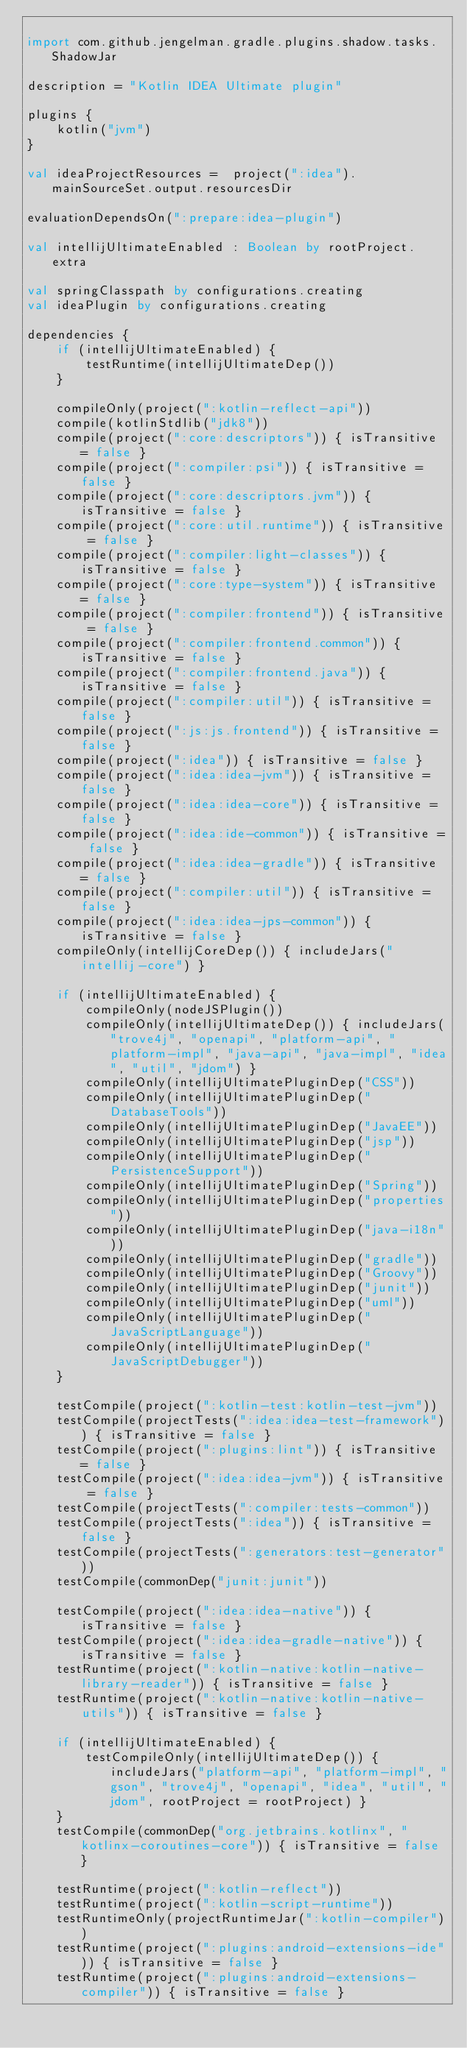<code> <loc_0><loc_0><loc_500><loc_500><_Kotlin_>
import com.github.jengelman.gradle.plugins.shadow.tasks.ShadowJar

description = "Kotlin IDEA Ultimate plugin"

plugins {
    kotlin("jvm")
}

val ideaProjectResources =  project(":idea").mainSourceSet.output.resourcesDir

evaluationDependsOn(":prepare:idea-plugin")

val intellijUltimateEnabled : Boolean by rootProject.extra

val springClasspath by configurations.creating
val ideaPlugin by configurations.creating

dependencies {
    if (intellijUltimateEnabled) {
        testRuntime(intellijUltimateDep())
    }

    compileOnly(project(":kotlin-reflect-api"))
    compile(kotlinStdlib("jdk8"))
    compile(project(":core:descriptors")) { isTransitive = false }
    compile(project(":compiler:psi")) { isTransitive = false }
    compile(project(":core:descriptors.jvm")) { isTransitive = false }
    compile(project(":core:util.runtime")) { isTransitive = false }
    compile(project(":compiler:light-classes")) { isTransitive = false }
    compile(project(":core:type-system")) { isTransitive = false }
    compile(project(":compiler:frontend")) { isTransitive = false }
    compile(project(":compiler:frontend.common")) { isTransitive = false }
    compile(project(":compiler:frontend.java")) { isTransitive = false }
    compile(project(":compiler:util")) { isTransitive = false }
    compile(project(":js:js.frontend")) { isTransitive = false }
    compile(project(":idea")) { isTransitive = false }
    compile(project(":idea:idea-jvm")) { isTransitive = false }
    compile(project(":idea:idea-core")) { isTransitive = false }
    compile(project(":idea:ide-common")) { isTransitive = false }
    compile(project(":idea:idea-gradle")) { isTransitive = false }
    compile(project(":compiler:util")) { isTransitive = false }
    compile(project(":idea:idea-jps-common")) { isTransitive = false }
    compileOnly(intellijCoreDep()) { includeJars("intellij-core") }

    if (intellijUltimateEnabled) {
        compileOnly(nodeJSPlugin())
        compileOnly(intellijUltimateDep()) { includeJars("trove4j", "openapi", "platform-api", "platform-impl", "java-api", "java-impl", "idea", "util", "jdom") }
        compileOnly(intellijUltimatePluginDep("CSS"))
        compileOnly(intellijUltimatePluginDep("DatabaseTools"))
        compileOnly(intellijUltimatePluginDep("JavaEE"))
        compileOnly(intellijUltimatePluginDep("jsp"))
        compileOnly(intellijUltimatePluginDep("PersistenceSupport"))
        compileOnly(intellijUltimatePluginDep("Spring"))
        compileOnly(intellijUltimatePluginDep("properties"))
        compileOnly(intellijUltimatePluginDep("java-i18n"))
        compileOnly(intellijUltimatePluginDep("gradle"))
        compileOnly(intellijUltimatePluginDep("Groovy"))
        compileOnly(intellijUltimatePluginDep("junit"))
        compileOnly(intellijUltimatePluginDep("uml"))
        compileOnly(intellijUltimatePluginDep("JavaScriptLanguage"))
        compileOnly(intellijUltimatePluginDep("JavaScriptDebugger"))
    }

    testCompile(project(":kotlin-test:kotlin-test-jvm"))
    testCompile(projectTests(":idea:idea-test-framework")) { isTransitive = false }
    testCompile(project(":plugins:lint")) { isTransitive = false }
    testCompile(project(":idea:idea-jvm")) { isTransitive = false }
    testCompile(projectTests(":compiler:tests-common"))
    testCompile(projectTests(":idea")) { isTransitive = false }
    testCompile(projectTests(":generators:test-generator"))
    testCompile(commonDep("junit:junit"))

    testCompile(project(":idea:idea-native")) { isTransitive = false }
    testCompile(project(":idea:idea-gradle-native")) { isTransitive = false }
    testRuntime(project(":kotlin-native:kotlin-native-library-reader")) { isTransitive = false }
    testRuntime(project(":kotlin-native:kotlin-native-utils")) { isTransitive = false }

    if (intellijUltimateEnabled) {
        testCompileOnly(intellijUltimateDep()) { includeJars("platform-api", "platform-impl", "gson", "trove4j", "openapi", "idea", "util", "jdom", rootProject = rootProject) }
    }
    testCompile(commonDep("org.jetbrains.kotlinx", "kotlinx-coroutines-core")) { isTransitive = false }

    testRuntime(project(":kotlin-reflect"))
    testRuntime(project(":kotlin-script-runtime"))
    testRuntimeOnly(projectRuntimeJar(":kotlin-compiler"))
    testRuntime(project(":plugins:android-extensions-ide")) { isTransitive = false }
    testRuntime(project(":plugins:android-extensions-compiler")) { isTransitive = false }</code> 